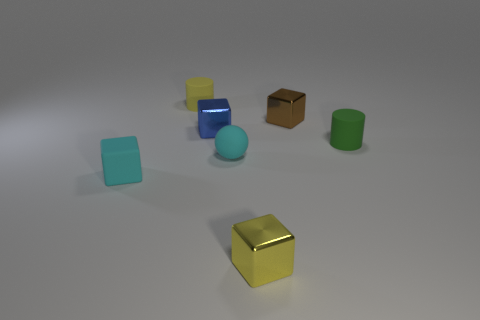Add 1 tiny blue matte objects. How many objects exist? 8 Subtract all cubes. How many objects are left? 3 Subtract 1 yellow cylinders. How many objects are left? 6 Subtract all small blue rubber balls. Subtract all brown metal objects. How many objects are left? 6 Add 7 brown shiny things. How many brown shiny things are left? 8 Add 4 brown objects. How many brown objects exist? 5 